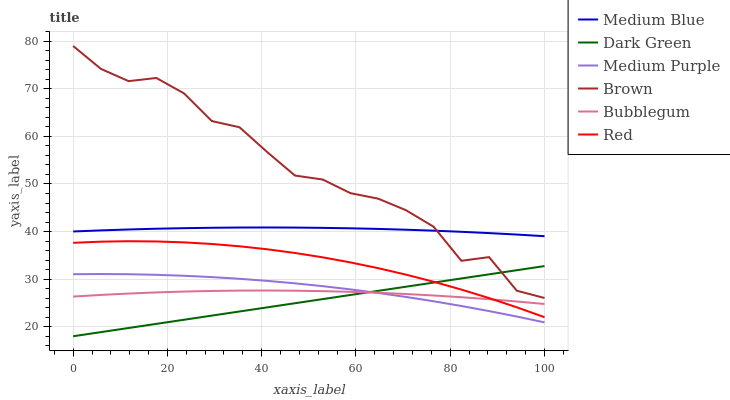Does Dark Green have the minimum area under the curve?
Answer yes or no. Yes. Does Brown have the maximum area under the curve?
Answer yes or no. Yes. Does Medium Blue have the minimum area under the curve?
Answer yes or no. No. Does Medium Blue have the maximum area under the curve?
Answer yes or no. No. Is Dark Green the smoothest?
Answer yes or no. Yes. Is Brown the roughest?
Answer yes or no. Yes. Is Medium Blue the smoothest?
Answer yes or no. No. Is Medium Blue the roughest?
Answer yes or no. No. Does Dark Green have the lowest value?
Answer yes or no. Yes. Does Bubblegum have the lowest value?
Answer yes or no. No. Does Brown have the highest value?
Answer yes or no. Yes. Does Medium Blue have the highest value?
Answer yes or no. No. Is Dark Green less than Medium Blue?
Answer yes or no. Yes. Is Brown greater than Bubblegum?
Answer yes or no. Yes. Does Bubblegum intersect Medium Purple?
Answer yes or no. Yes. Is Bubblegum less than Medium Purple?
Answer yes or no. No. Is Bubblegum greater than Medium Purple?
Answer yes or no. No. Does Dark Green intersect Medium Blue?
Answer yes or no. No. 